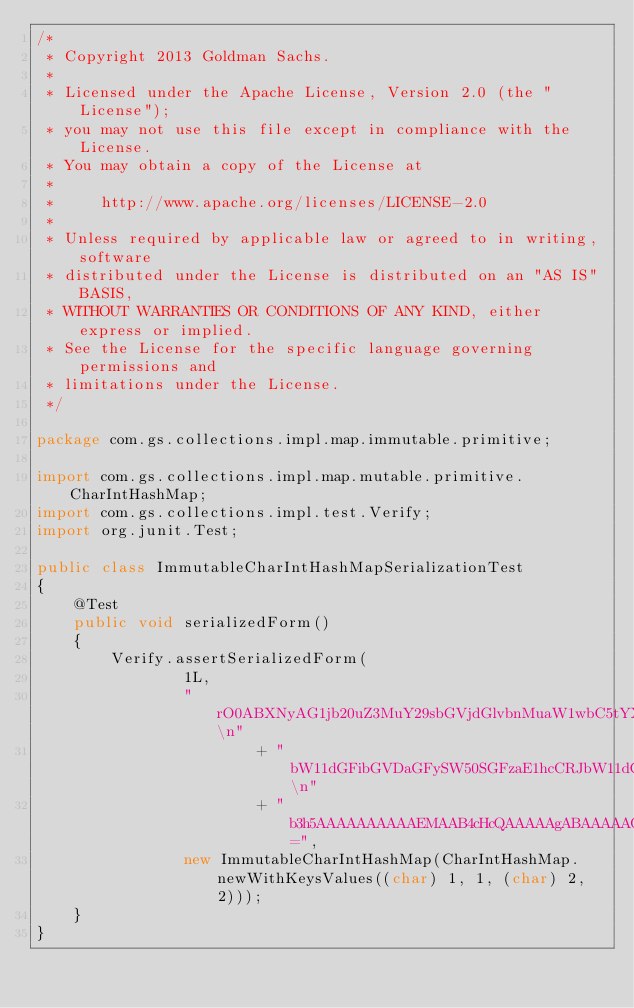<code> <loc_0><loc_0><loc_500><loc_500><_Java_>/*
 * Copyright 2013 Goldman Sachs.
 *
 * Licensed under the Apache License, Version 2.0 (the "License");
 * you may not use this file except in compliance with the License.
 * You may obtain a copy of the License at
 *
 *     http://www.apache.org/licenses/LICENSE-2.0
 *
 * Unless required by applicable law or agreed to in writing, software
 * distributed under the License is distributed on an "AS IS" BASIS,
 * WITHOUT WARRANTIES OR CONDITIONS OF ANY KIND, either express or implied.
 * See the License for the specific language governing permissions and
 * limitations under the License.
 */

package com.gs.collections.impl.map.immutable.primitive;

import com.gs.collections.impl.map.mutable.primitive.CharIntHashMap;
import com.gs.collections.impl.test.Verify;
import org.junit.Test;

public class ImmutableCharIntHashMapSerializationTest
{
    @Test
    public void serializedForm()
    {
        Verify.assertSerializedForm(
                1L,
                "rO0ABXNyAG1jb20uZ3MuY29sbGVjdGlvbnMuaW1wbC5tYXAuaW1tdXRhYmxlLnByaW1pdGl2ZS5J\n"
                        + "bW11dGFibGVDaGFySW50SGFzaE1hcCRJbW11dGFibGVDaGFySW50TWFwU2VyaWFsaXphdGlvblBy\n"
                        + "b3h5AAAAAAAAAAEMAAB4cHcQAAAAAgABAAAAAQACAAAAAng=",
                new ImmutableCharIntHashMap(CharIntHashMap.newWithKeysValues((char) 1, 1, (char) 2, 2)));
    }
}
</code> 